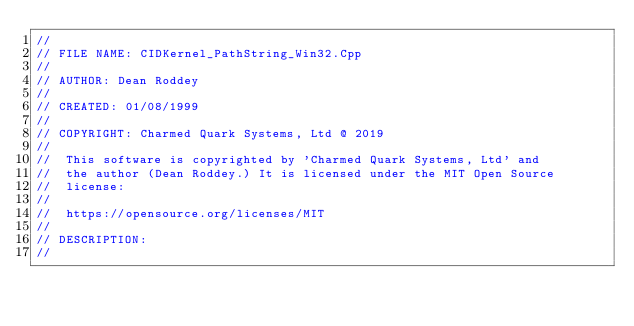<code> <loc_0><loc_0><loc_500><loc_500><_C++_>//
// FILE NAME: CIDKernel_PathString_Win32.Cpp
//
// AUTHOR: Dean Roddey
//
// CREATED: 01/08/1999
//
// COPYRIGHT: Charmed Quark Systems, Ltd @ 2019
//
//  This software is copyrighted by 'Charmed Quark Systems, Ltd' and
//  the author (Dean Roddey.) It is licensed under the MIT Open Source
//  license:
//
//  https://opensource.org/licenses/MIT
//
// DESCRIPTION:
//</code> 